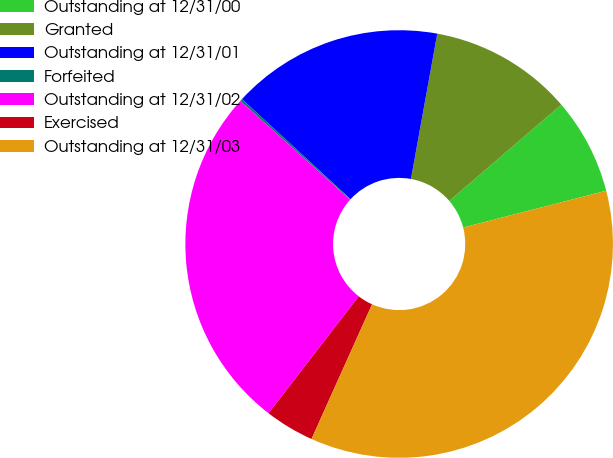Convert chart to OTSL. <chart><loc_0><loc_0><loc_500><loc_500><pie_chart><fcel>Outstanding at 12/31/00<fcel>Granted<fcel>Outstanding at 12/31/01<fcel>Forfeited<fcel>Outstanding at 12/31/02<fcel>Exercised<fcel>Outstanding at 12/31/03<nl><fcel>7.29%<fcel>10.85%<fcel>16.0%<fcel>0.18%<fcel>26.21%<fcel>3.74%<fcel>35.73%<nl></chart> 